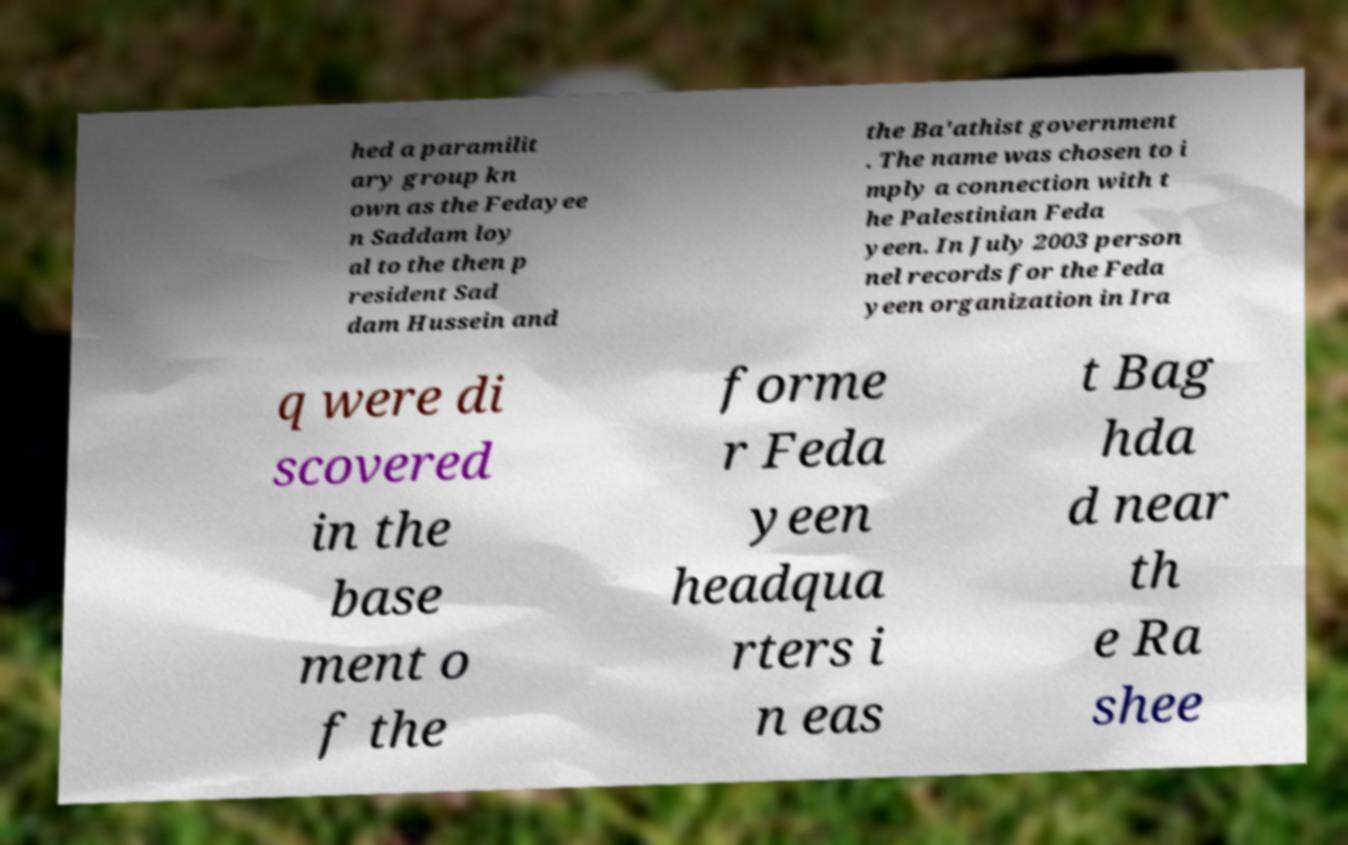Can you read and provide the text displayed in the image?This photo seems to have some interesting text. Can you extract and type it out for me? hed a paramilit ary group kn own as the Fedayee n Saddam loy al to the then p resident Sad dam Hussein and the Ba'athist government . The name was chosen to i mply a connection with t he Palestinian Feda yeen. In July 2003 person nel records for the Feda yeen organization in Ira q were di scovered in the base ment o f the forme r Feda yeen headqua rters i n eas t Bag hda d near th e Ra shee 